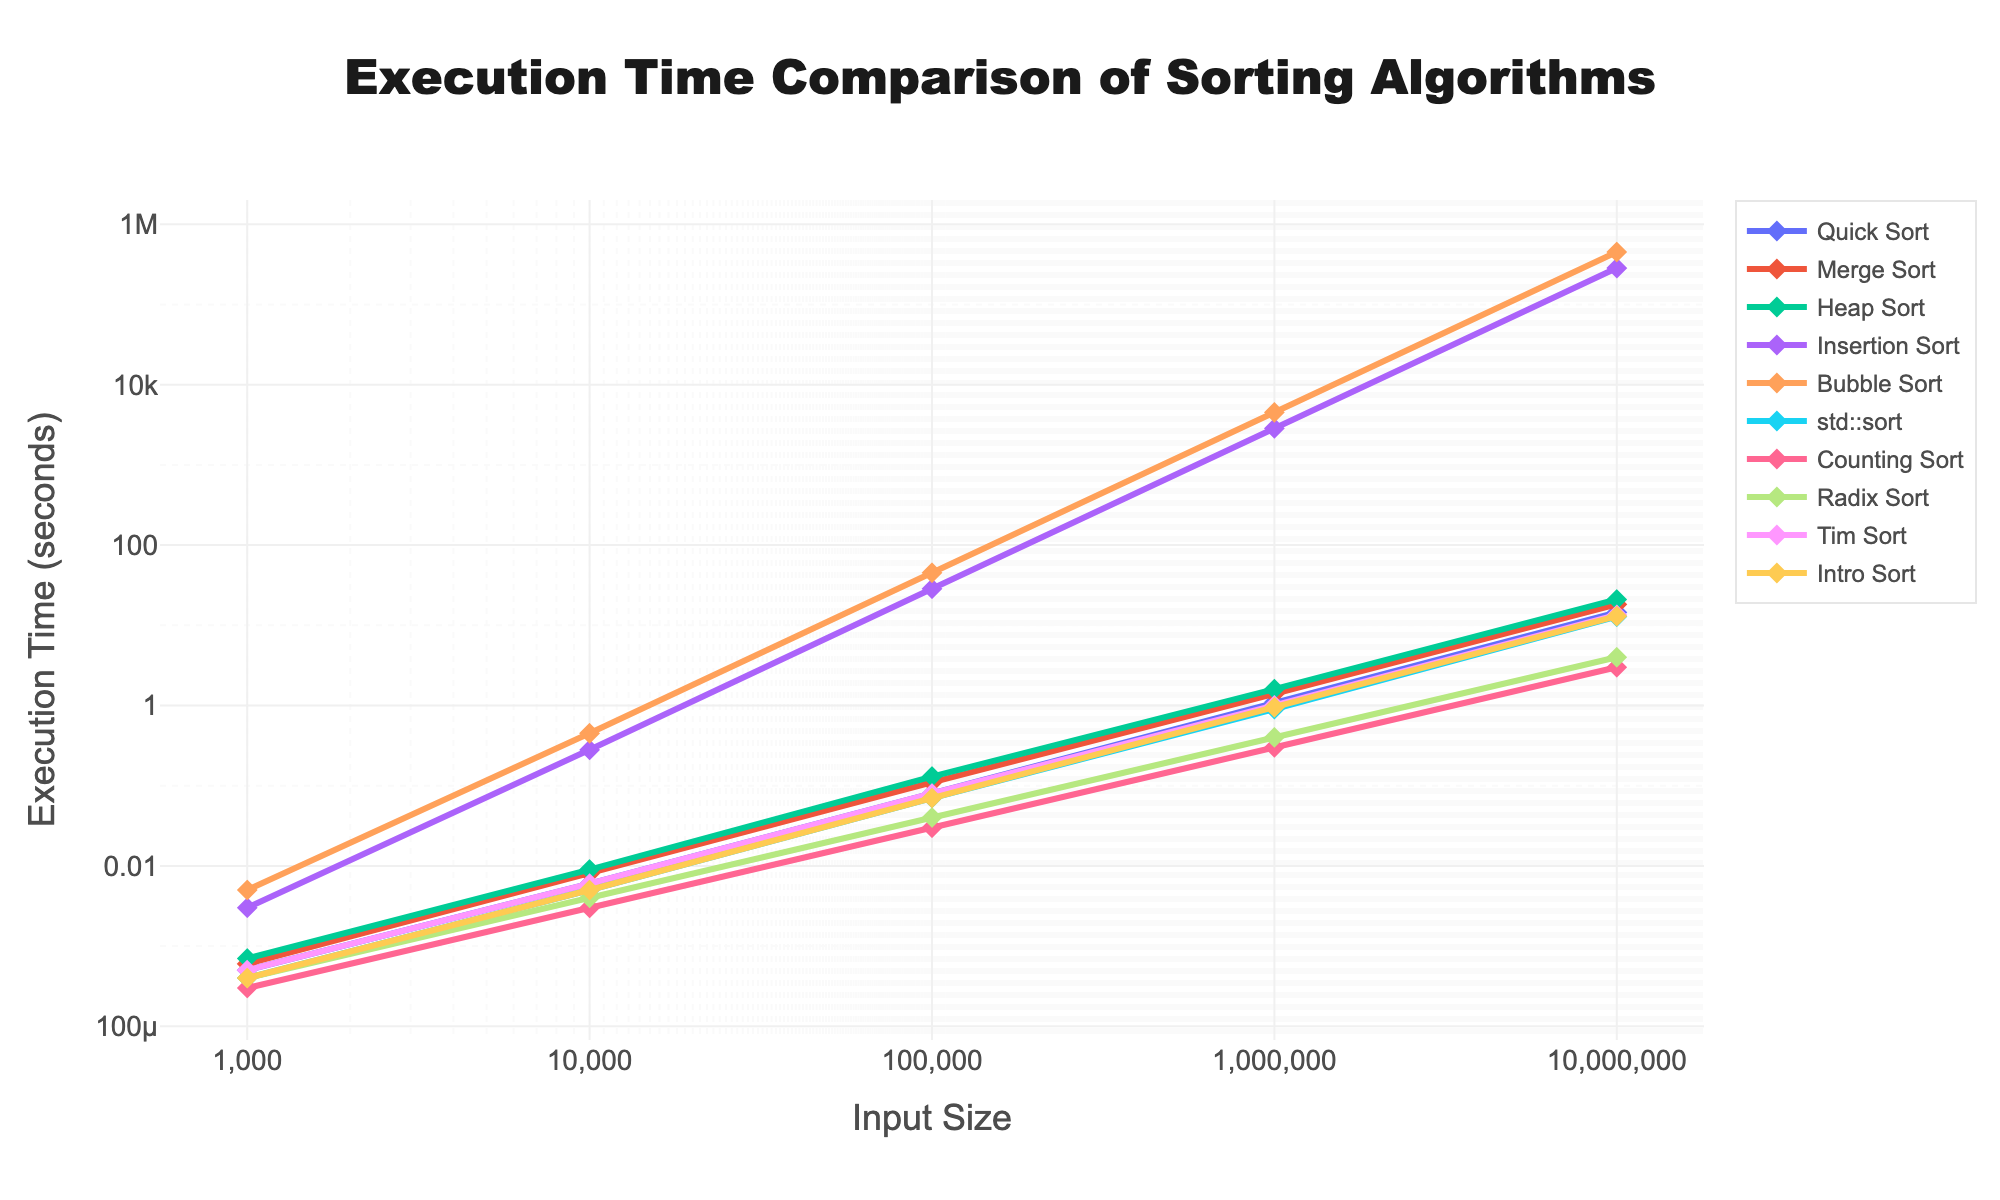what's the fastest algorithm for an input size of 10,000? The execution times for all algorithms at an input size of 10,000 are: Quick Sort (0.006), Merge Sort (0.008), Heap Sort (0.009), Insertion Sort (0.28), Bubble Sort (0.45), std::sort (0.005), Counting Sort (0.003), Radix Sort (0.004), Tim Sort (0.006), and Intro Sort (0.005). The smallest value is 0.003, which corresponds to Counting Sort
Answer: Counting Sort which algorithm has the steepest increase in execution time as input size grows? To determine the steepest increase, look at the trend of execution times for each algorithm from 1,000 to 10,000,000. The algorithm with the largest change is Insertion Sort, which goes from 0.003 to 285,000, showing exponential growth compared to others
Answer: Insertion Sort what's the median execution time for 1,000,000 input size across all algorithms? The execution times for input size 1,000,000 are: Quick Sort (1.1), Merge Sort (1.4), Heap Sort (1.6), Insertion Sort (2850), Bubble Sort (4520), std::sort (0.9), Counting Sort (0.3), Radix Sort (0.4), Tim Sort (1.0), and Intro Sort (0.95). Arranging them in ascending order: 0.3, 0.4, 0.9, 0.95, 1.0, 1.1, 1.4, 1.6, 2850, 4520. The median is the average of the 5th and 6th elements: (1.0 + 1.1)/2 = 1.05
Answer: 1.05 between Quick Sort and Merge Sort, which is more efficient for small input sizes, and how does it change for large input sizes? For input size 1,000: Quick Sort (0.0005) vs Merge Sort (0.0006), Quick Sort is faster. For 10,000: Quick Sort (0.006) vs Merge Sort (0.008), Quick Sort is faster. For 100,000: Quick Sort (0.08) vs Merge Sort (0.11), Quick Sort is faster. For 1,000,000: Quick Sort (1.1) vs Merge Sort (1.4), Quick Sort stays faster. For 10,000,000: Quick Sort (14.5) vs Merge Sort (18.2), Quick Sort is still faster
Answer: Quick Sort is more efficient for both small and large input sizes how does the execution time of Tim Sort compare with std::sort as input size increases? Compare the execution times for each input size: For 1,000: Tim Sort (0.0005) vs std::sort (0.0004), std::sort is faster. For 10,000: Tim Sort (0.006) vs std::sort (0.005), std::sort is faster. For 100,000: Tim Sort (0.08) vs std::sort (0.07), std::sort is faster. For 1,000,000: Tim Sort (1.0) vs std::sort (0.9), std::sort is faster. For 10,000,000: Tim Sort (13.5) vs std::sort (12.8), std::sort remains faster
Answer: std::sort is consistently faster as input size increases which algorithms exhibit a linear increase in execution time? Inspecting the trends, Counting Sort and Radix Sort demonstrate linear execution time increases from 1,000 to 10,000,000: Counting Sort (0.0003, 0.003, 0.03, 0.3, 3.0) and Radix Sort (0.0004, 0.004, 0.04, 0.4, 4.0) both show consistent linear progression
Answer: Counting Sort and Radix Sort 